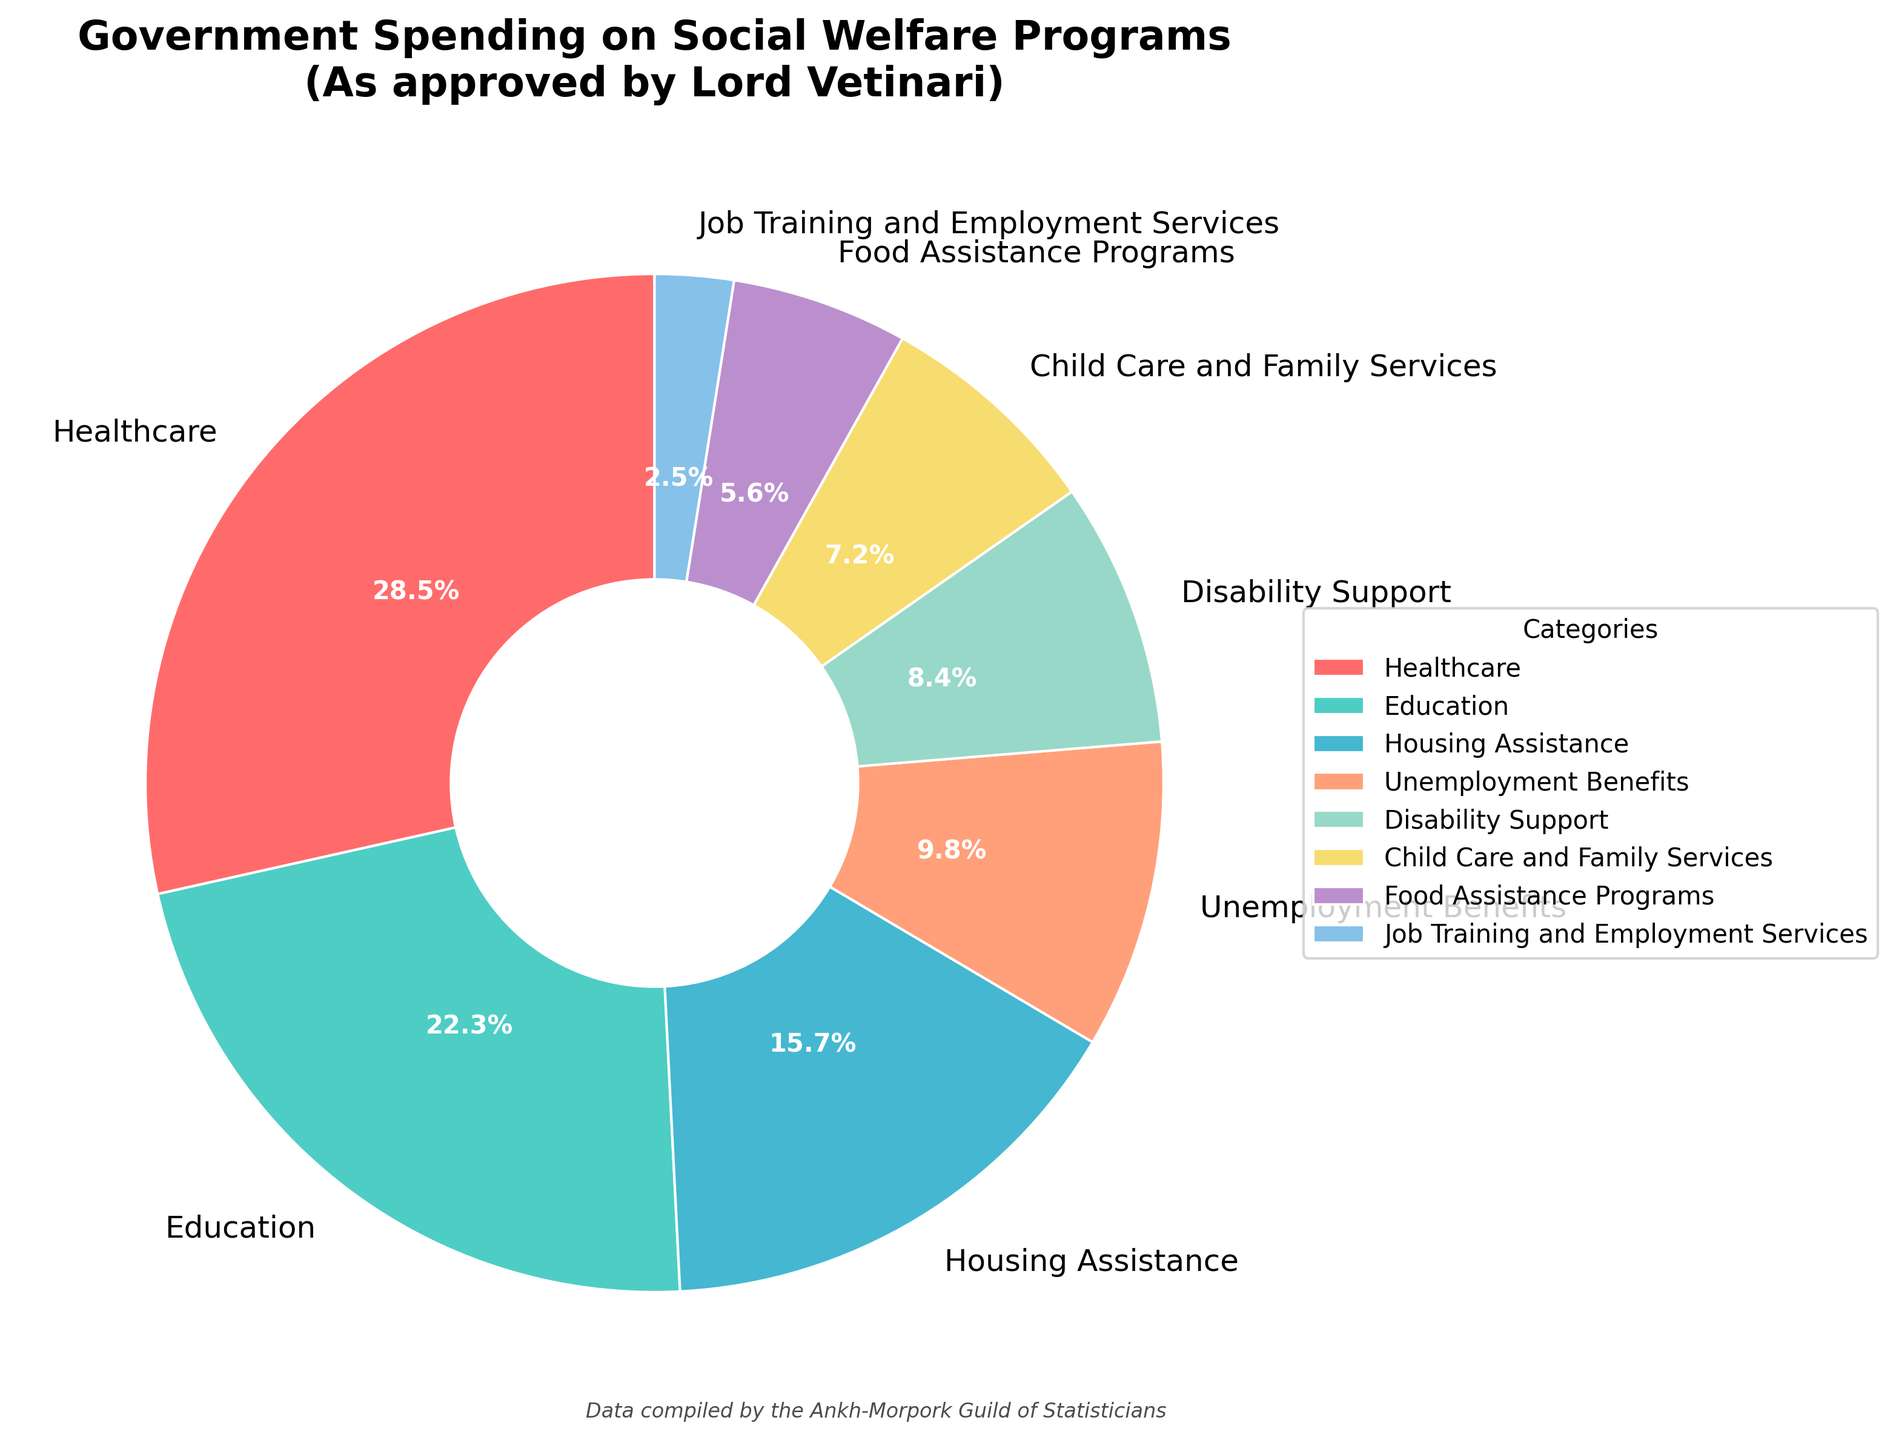What is the largest category of government spending on social welfare programs? The pie chart shows the largest segment is labeled "Healthcare" with a percentage of 28.5%.
Answer: Healthcare What is the combined percentage of spending on Education and Housing Assistance? According to the pie chart, Education is 22.3% and Housing Assistance is 15.7%, so the combined percentage is 22.3 + 15.7 = 38.0%.
Answer: 38.0% Which category has a higher percentage of spending: Child Care and Family Services or Food Assistance Programs? Child Care and Family Services has 7.2% while Food Assistance Programs have 5.6%, so Child Care and Family Services has a higher percentage.
Answer: Child Care and Family Services What is the difference in spending percentage between Education and Unemployment Benefits? From the pie chart, Education accounts for 22.3% and Unemployment Benefits account for 9.8%, so the difference is 22.3 - 9.8 = 12.5%.
Answer: 12.5% Are there any categories that have spending percentages lower than 5%? The only category with a percentage lower than 5% in the pie chart is Job Training and Employment Services, which is 2.5%.
Answer: Yes, Job Training and Employment Services In terms of visual comparison, which category is represented by the smallest slice on the pie chart? The smallest slice visually on the pie chart corresponds to the category "Job Training and Employment Services" with 2.5%.
Answer: Job Training and Employment Services What is the total percentage of spending on the two categories with the smallest slices? The two smallest slices are Job Training and Employment Services (2.5%) and Food Assistance Programs (5.6%). Their total percentage is 2.5 + 5.6 = 8.1%.
Answer: 8.1% How much more is spent on Healthcare compared to Disability Support? Healthcare has 28.5% and Disability Support has 8.4%. The difference is 28.5 - 8.4 = 20.1%.
Answer: 20.1% What is the average spending percentage for Healthcare, Education, and Housing Assistance? Adding the percentages for Healthcare, Education, and Housing Assistance gives 28.5 + 22.3 + 15.7 = 66.5%. The average is 66.5 / 3 = 22.17%.
Answer: 22.17% Which categories combined would approximately equal the percentage allocated to Healthcare? Education is 22.3% and Unemployment Benefits is 9.8%. Their combined percentage is close to Healthcare: 22.3 + 9.8 = 32.1% (Healthcare is 28.5%).
Answer: Education and Unemployment Benefits 